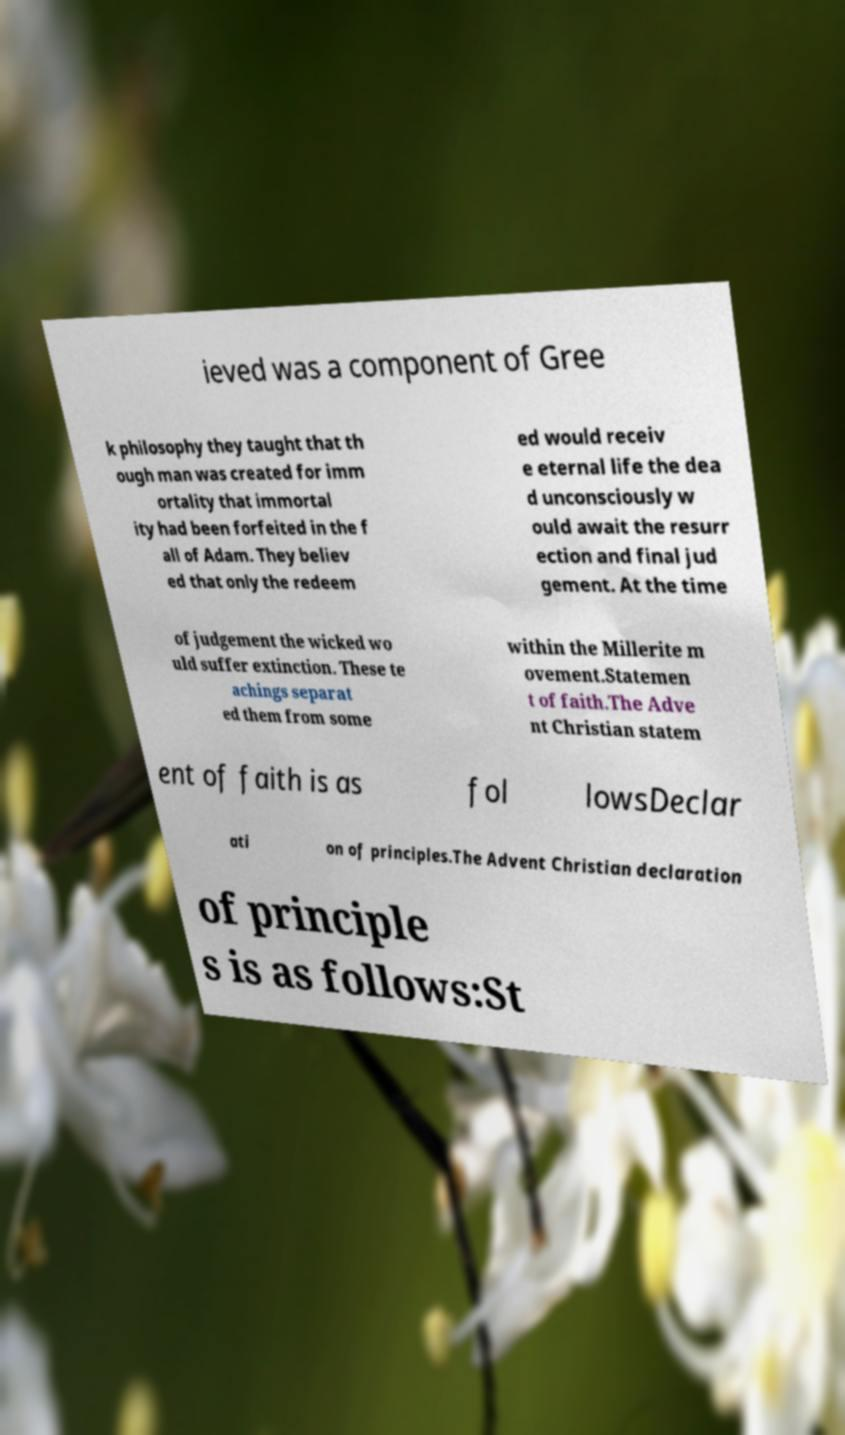Please identify and transcribe the text found in this image. ieved was a component of Gree k philosophy they taught that th ough man was created for imm ortality that immortal ity had been forfeited in the f all of Adam. They believ ed that only the redeem ed would receiv e eternal life the dea d unconsciously w ould await the resurr ection and final jud gement. At the time of judgement the wicked wo uld suffer extinction. These te achings separat ed them from some within the Millerite m ovement.Statemen t of faith.The Adve nt Christian statem ent of faith is as fol lowsDeclar ati on of principles.The Advent Christian declaration of principle s is as follows:St 